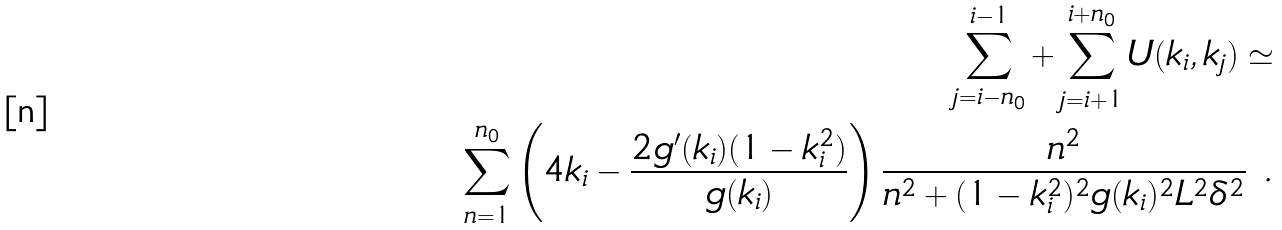Convert formula to latex. <formula><loc_0><loc_0><loc_500><loc_500>\sum _ { j = i - n _ { 0 } } ^ { i - 1 } + \sum _ { j = i + 1 } ^ { i + n _ { 0 } } U ( k _ { i } , k _ { j } ) \simeq \\ \sum _ { n = 1 } ^ { n _ { 0 } } \left ( 4 k _ { i } - \frac { 2 g ^ { \prime } ( k _ { i } ) ( 1 - k _ { i } ^ { 2 } ) } { g ( k _ { i } ) } \right ) \frac { n ^ { 2 } } { n ^ { 2 } + ( 1 - k _ { i } ^ { 2 } ) ^ { 2 } g ( k _ { i } ) ^ { 2 } L ^ { 2 } \delta ^ { 2 } } \ .</formula> 